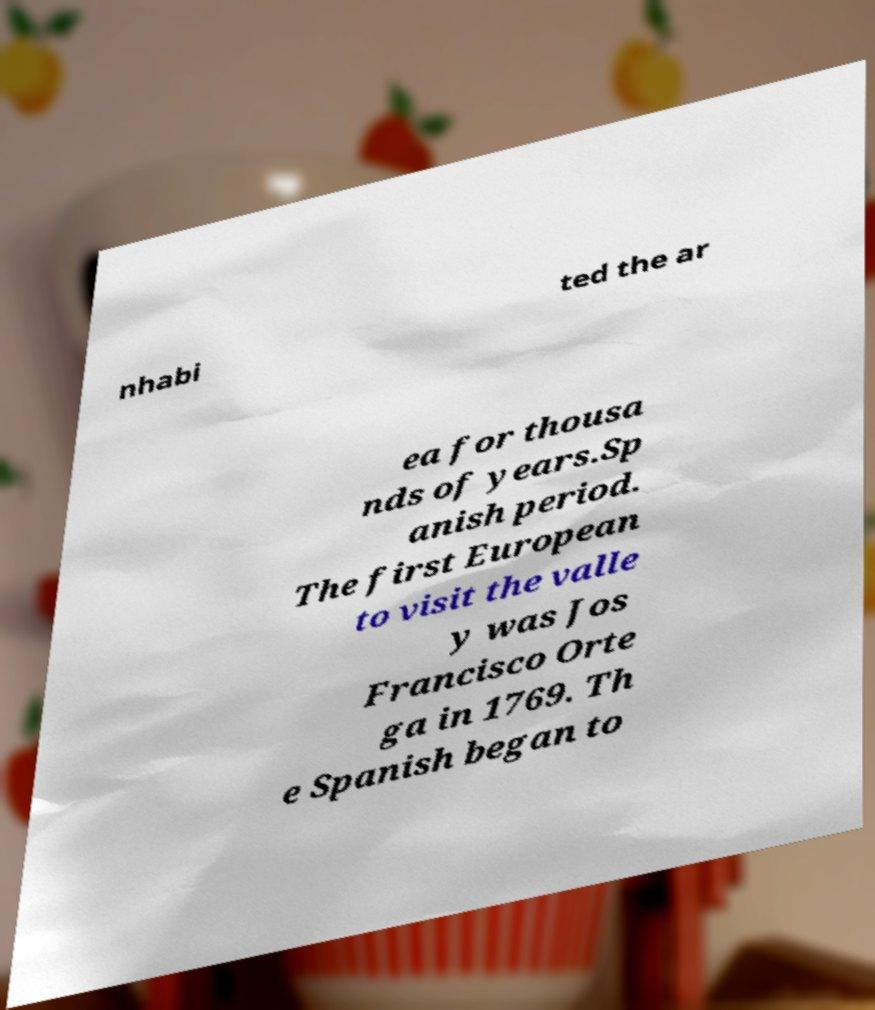Please read and relay the text visible in this image. What does it say? nhabi ted the ar ea for thousa nds of years.Sp anish period. The first European to visit the valle y was Jos Francisco Orte ga in 1769. Th e Spanish began to 